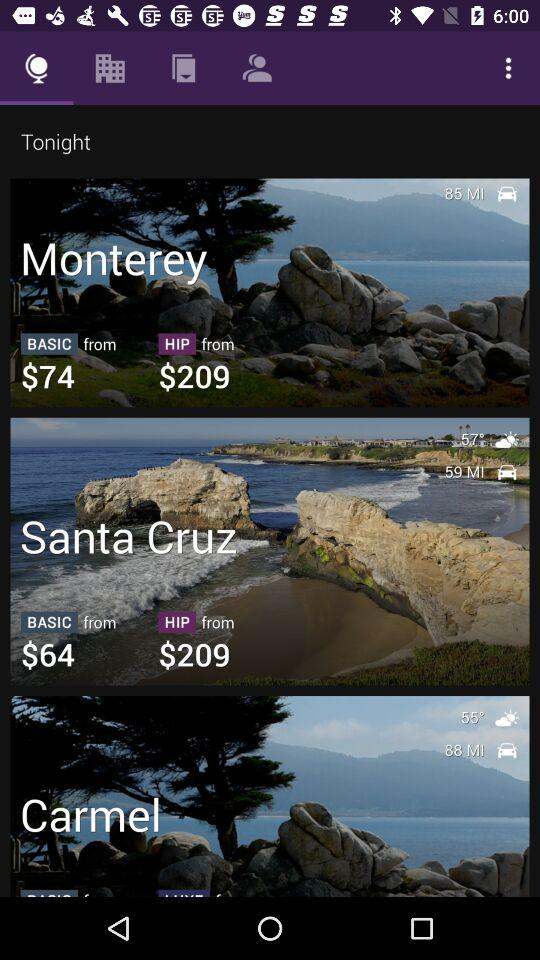What's the weather like in Monterey right now?
When the provided information is insufficient, respond with <no answer>. <no answer> 